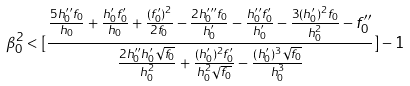Convert formula to latex. <formula><loc_0><loc_0><loc_500><loc_500>\beta _ { 0 } ^ { 2 } < [ \frac { \frac { 5 h _ { 0 } ^ { \prime \prime } f _ { 0 } } { h _ { 0 } } + \frac { h _ { 0 } ^ { \prime } f _ { 0 } ^ { \prime } } { h _ { 0 } } + \frac { ( f _ { 0 } ^ { \prime } ) ^ { 2 } } { 2 f _ { 0 } } - \frac { 2 h _ { 0 } ^ { \prime \prime \prime } f _ { 0 } } { h _ { 0 } ^ { \prime } } - \frac { h _ { 0 } ^ { \prime \prime } f _ { 0 } ^ { \prime } } { h _ { 0 } ^ { \prime } } - \frac { 3 ( h _ { 0 } ^ { \prime } ) ^ { 2 } f _ { 0 } } { h _ { 0 } ^ { 2 } } - f _ { 0 } ^ { \prime \prime } } { \frac { 2 h _ { 0 } ^ { \prime \prime } h _ { 0 } ^ { \prime } \sqrt { f _ { 0 } } } { h _ { 0 } ^ { 2 } } + \frac { ( h _ { 0 } ^ { \prime } ) ^ { 2 } f _ { 0 } ^ { \prime } } { h _ { 0 } ^ { 2 } \sqrt { f _ { 0 } } } - \frac { ( h _ { 0 } ^ { \prime } ) ^ { 3 } \sqrt { f _ { 0 } } } { h _ { 0 } ^ { 3 } } } ] - 1</formula> 